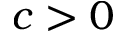Convert formula to latex. <formula><loc_0><loc_0><loc_500><loc_500>c > 0</formula> 